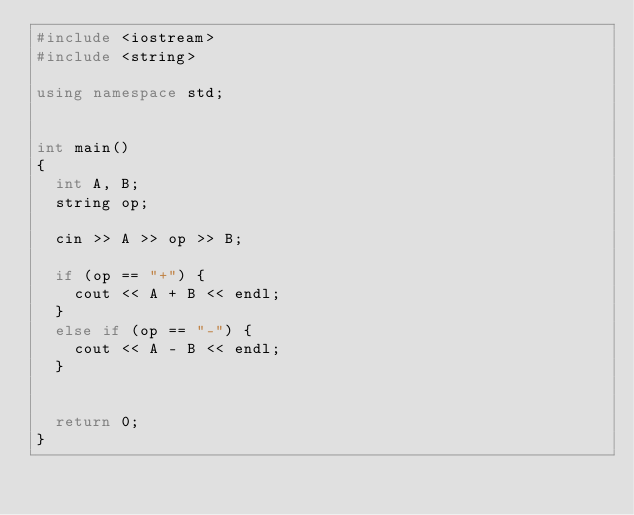Convert code to text. <code><loc_0><loc_0><loc_500><loc_500><_C++_>#include <iostream>
#include <string>

using namespace std;


int main()
{
	int A, B;
	string op;

	cin >> A >> op >> B;

	if (op == "+") {
		cout << A + B << endl;
	}
	else if (op == "-") {
		cout << A - B << endl;
	}
	

	return 0;
}</code> 